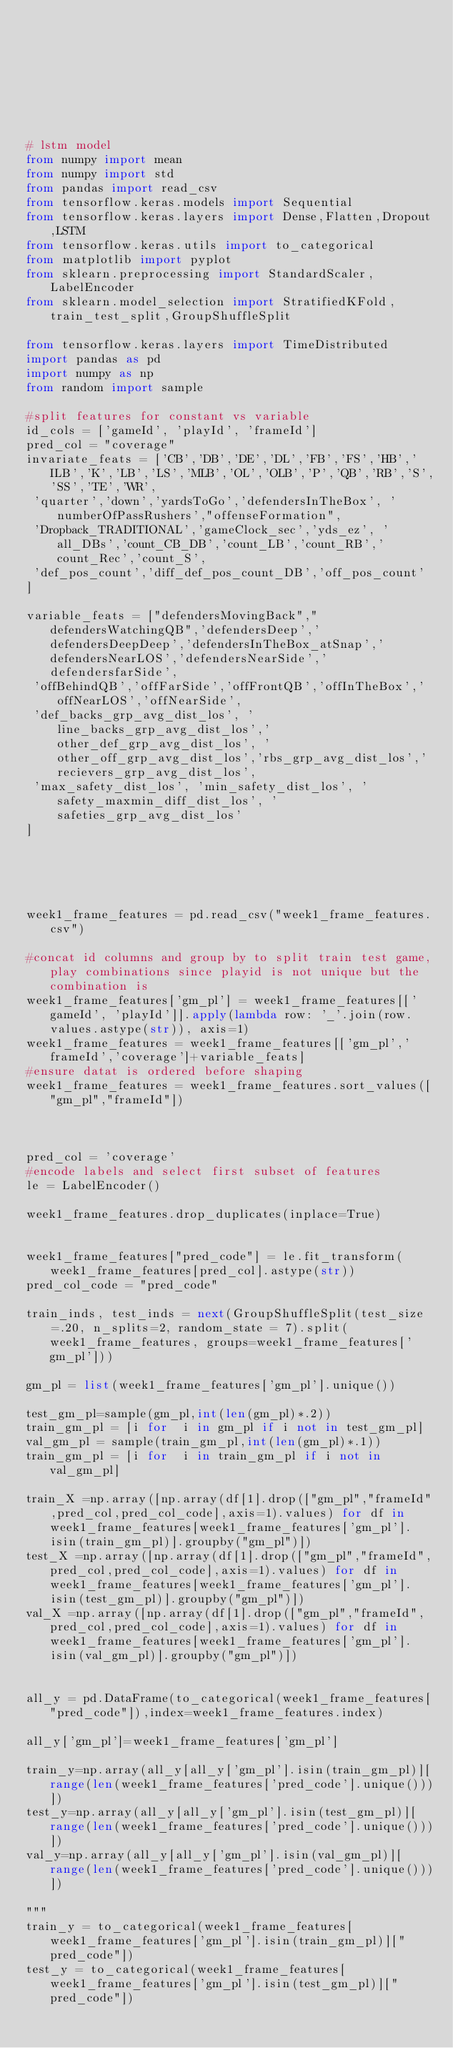<code> <loc_0><loc_0><loc_500><loc_500><_Python_>







# lstm model
from numpy import mean
from numpy import std
from pandas import read_csv
from tensorflow.keras.models import Sequential
from tensorflow.keras.layers import Dense,Flatten,Dropout,LSTM
from tensorflow.keras.utils import to_categorical
from matplotlib import pyplot
from sklearn.preprocessing import StandardScaler,LabelEncoder
from sklearn.model_selection import StratifiedKFold,train_test_split,GroupShuffleSplit

from tensorflow.keras.layers import TimeDistributed
import pandas as pd
import numpy as np
from random import sample

#split features for constant vs variable
id_cols = ['gameId', 'playId', 'frameId'] 
pred_col = "coverage"
invariate_feats = ['CB','DB','DE','DL','FB','FS','HB','ILB','K','LB','LS','MLB','OL','OLB','P','QB','RB','S','SS','TE','WR',
 'quarter','down','yardsToGo','defendersInTheBox', 'numberOfPassRushers',"offenseFormation",
 'Dropback_TRADITIONAL','gameClock_sec','yds_ez', 'all_DBs','count_CB_DB','count_LB','count_RB','count_Rec','count_S',
 'def_pos_count','diff_def_pos_count_DB','off_pos_count'
]

variable_feats = ["defendersMovingBack","defendersWatchingQB",'defendersDeep','defendersDeepDeep','defendersInTheBox_atSnap','defendersNearLOS','defendersNearSide','defendersfarSide',
 'offBehindQB','offFarSide','offFrontQB','offInTheBox','offNearLOS','offNearSide',
 'def_backs_grp_avg_dist_los', 'line_backs_grp_avg_dist_los','other_def_grp_avg_dist_los', 'other_off_grp_avg_dist_los','rbs_grp_avg_dist_los','recievers_grp_avg_dist_los',
 'max_safety_dist_los', 'min_safety_dist_los', 'safety_maxmin_diff_dist_los', 'safeties_grp_avg_dist_los'
]





week1_frame_features = pd.read_csv("week1_frame_features.csv")

#concat id columns and group by to split train test game,play combinations since playid is not unique but the combination is
week1_frame_features['gm_pl'] = week1_frame_features[['gameId', 'playId']].apply(lambda row: '_'.join(row.values.astype(str)), axis=1)
week1_frame_features = week1_frame_features[['gm_pl','frameId','coverage']+variable_feats]
#ensure datat is ordered before shaping
week1_frame_features = week1_frame_features.sort_values(["gm_pl","frameId"])



pred_col = 'coverage'
#encode labels and select first subset of features
le = LabelEncoder()

week1_frame_features.drop_duplicates(inplace=True)


week1_frame_features["pred_code"] = le.fit_transform(week1_frame_features[pred_col].astype(str))
pred_col_code = "pred_code"

train_inds, test_inds = next(GroupShuffleSplit(test_size=.20, n_splits=2, random_state = 7).split(week1_frame_features, groups=week1_frame_features['gm_pl']))

gm_pl = list(week1_frame_features['gm_pl'].unique())

test_gm_pl=sample(gm_pl,int(len(gm_pl)*.2))
train_gm_pl = [i for  i in gm_pl if i not in test_gm_pl]
val_gm_pl = sample(train_gm_pl,int(len(gm_pl)*.1))
train_gm_pl = [i for  i in train_gm_pl if i not in val_gm_pl]

train_X =np.array([np.array(df[1].drop(["gm_pl","frameId",pred_col,pred_col_code],axis=1).values) for df in week1_frame_features[week1_frame_features['gm_pl'].isin(train_gm_pl)].groupby("gm_pl")])
test_X =np.array([np.array(df[1].drop(["gm_pl","frameId",pred_col,pred_col_code],axis=1).values) for df in week1_frame_features[week1_frame_features['gm_pl'].isin(test_gm_pl)].groupby("gm_pl")])
val_X =np.array([np.array(df[1].drop(["gm_pl","frameId",pred_col,pred_col_code],axis=1).values) for df in week1_frame_features[week1_frame_features['gm_pl'].isin(val_gm_pl)].groupby("gm_pl")])


all_y = pd.DataFrame(to_categorical(week1_frame_features["pred_code"]),index=week1_frame_features.index)

all_y['gm_pl']=week1_frame_features['gm_pl']

train_y=np.array(all_y[all_y['gm_pl'].isin(train_gm_pl)][range(len(week1_frame_features['pred_code'].unique()))])
test_y=np.array(all_y[all_y['gm_pl'].isin(test_gm_pl)][range(len(week1_frame_features['pred_code'].unique()))])
val_y=np.array(all_y[all_y['gm_pl'].isin(val_gm_pl)][range(len(week1_frame_features['pred_code'].unique()))])

"""
train_y = to_categorical(week1_frame_features[week1_frame_features['gm_pl'].isin(train_gm_pl)]["pred_code"])
test_y = to_categorical(week1_frame_features[week1_frame_features['gm_pl'].isin(test_gm_pl)]["pred_code"])</code> 